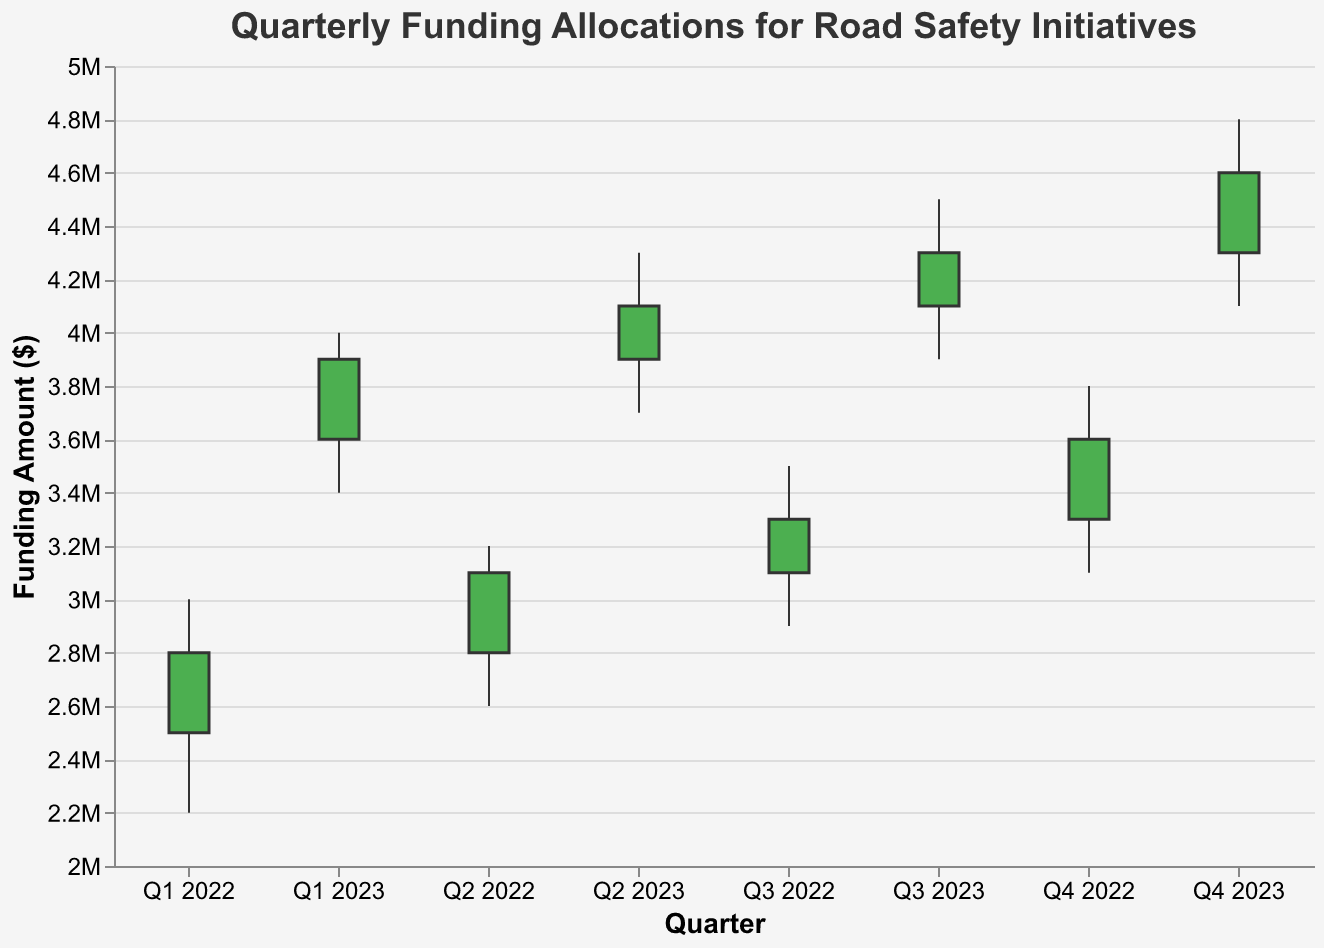Who has seen the highest funding allocation? To identify the highest funding allocation, look for the highest "High" value across all quarters. The highest value is 4,800,000 in Q4 2023.
Answer: Q4 2023 What's the overall trend in quarterly funding allocations from Q1 2022 to Q4 2023? Look at the "Open" and "Close" values from Q1 2022 to Q4 2023. Both values show a consistent upward trend over the quarters, indicating increasing funding allocations.
Answer: Increasing Trend Which quarter had the smallest variation in funding allocation? The variation in funding allocation can be measured by the range, which is the difference between "High" and "Low" values. Q1 2022 had the smallest variation with a range of 800,000 (3,000,000 - 2,200,000).
Answer: Q1 2022 How did the funding allocation change from Q3 2022 to Q4 2022? Compare the "Close" value of Q3 2022 and the "Open" value of Q4 2022. The "Close" of Q3 2022 is 3,300,000, and the "Open" of Q4 2022 is 3,300,000, showing no change between these quarters.
Answer: No Change What was the largest budget increase between consecutive quarters? Calculate the difference in "Close" values between consecutive quarters. The largest increase is from Q4 2023 to Q1 2023 (3,600,000 to 3,900,000), which is an increase of 300,000.
Answer: 300,000 Do any quarters show a decrease in funding allocation? Identify quarters where the "Close" value is lower than the "Open" value. None of the quarters show a decrease as the "Close" value is always higher than the "Open" value.
Answer: No How much did the funding amount differ between the highest and lowest allocation in Q2 2023? Find the difference between the "High" and "Low" values for Q2 2023. The difference is 600,000 (4,300,000 - 3,700,000).
Answer: 600,000 Which quarters saw a closing funding allocation higher than 3,500,000? Look for quarters where the "Close" value is greater than 3,500,000. These quarters are Q4 2022, Q1 2023, Q2 2023, Q3 2023, and Q4 2023.
Answer: Q4 2022, Q1 2023, Q2 2023, Q3 2023, Q4 2023 What was the funding trend from Q2 2022 to Q3 2023? Look at the "Open" and "Close" values from Q2 2022 (Open: 2,800,000, Close: 3,100,000) to Q3 2023 (Open: 4,100,000, Close: 4,300,000). The funding trend is consistently increasing for each quarter in this period.
Answer: Increasing Trend 